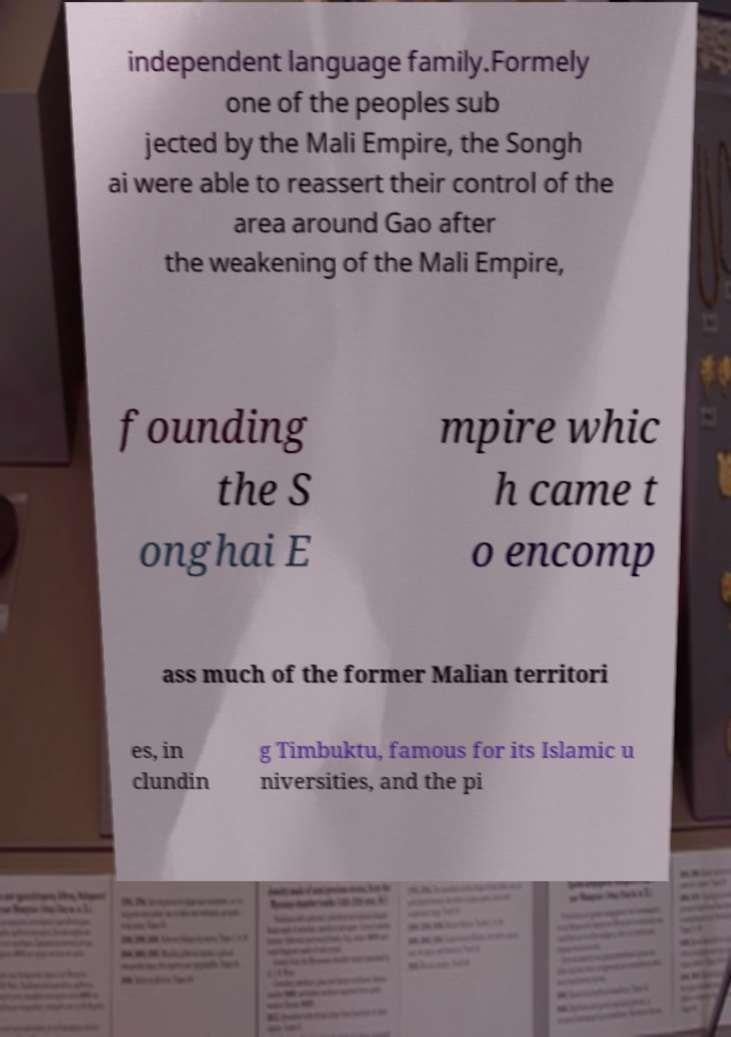Please read and relay the text visible in this image. What does it say? independent language family.Formely one of the peoples sub jected by the Mali Empire, the Songh ai were able to reassert their control of the area around Gao after the weakening of the Mali Empire, founding the S onghai E mpire whic h came t o encomp ass much of the former Malian territori es, in clundin g Timbuktu, famous for its Islamic u niversities, and the pi 